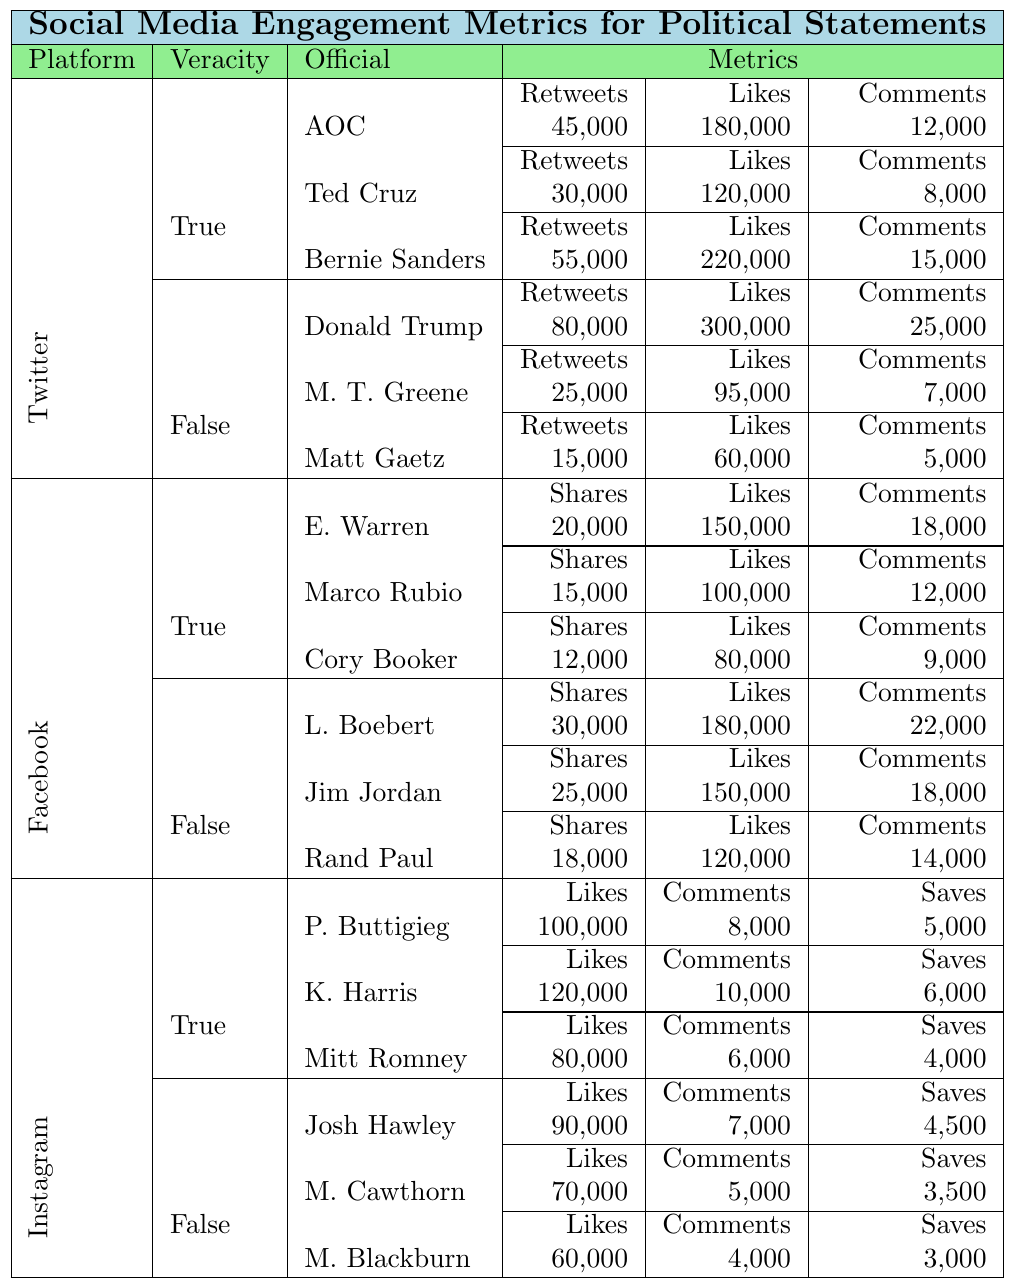What social media platform had the highest engagement for false statements? The highest engagement for false statements can be found by comparing the total of retweets, likes, and comments across the platforms. Twitter's highest false statement engagement is from Donald Trump with 80,000 retweets, 300,000 likes, and 25,000 comments, totaling 405,000. This is higher than other platforms' totals.
Answer: Twitter What is the total number of likes for true statements made by Alexandria Ocasio-Cortez and Bernie Sanders on Twitter? For Alexandria Ocasio-Cortez, the likes total 180,000 and for Bernie Sanders it is 220,000. The total likes are 180,000 + 220,000 = 400,000.
Answer: 400,000 Which official received the most comments for true statements on Facebook? The official with the most comments for true statements on Facebook is Elizabeth Warren, who received 18,000 comments.
Answer: Elizabeth Warren Did Marjorie Taylor Greene have more likes or comments for false statements on Twitter? Marjorie Taylor Greene received 95,000 likes and 7,000 comments for false statements. Since 95,000 is greater than 7,000, she had more likes than comments.
Answer: Likes What is the average engagement (retweets, likes, comments) for true statements on Twitter? To find the average engagement for true statements, sum the metrics: (45,000 + 180,000 + 12,000) + (30,000 + 120,000 + 8,000) + (55,000 + 220,000 + 15,000) = 450,000. There are 9 data points (3 metrics × 3 officials). Average is 450,000 / 9 = 50,000.
Answer: 50,000 Which social media platform had the least engagement for true statements? Calculate the total for true statements on each platform: Twitter (450,000), Facebook (320,000), Instagram (360,000). Facebook has the least engagement at 320,000.
Answer: Facebook How many total shares were there for false statements on Facebook from all officials? Lauren Boebert had 30,000 shares, Jim Jordan had 25,000 shares, and Rand Paul had 18,000 shares. The total is 30,000 + 25,000 + 18,000 = 73,000 shares.
Answer: 73,000 Which official had the highest number of likes for false statements on Instagram? On Instagram, Josh Hawley had 90,000 likes for false statements, which is the highest among the officials listed.
Answer: Josh Hawley Calculate the difference in comments between true statements by Cory Booker and false statements by Rand Paul on Facebook. Cory Booker had 9,000 comments for true statements, and Rand Paul had 14,000 comments for false statements. The difference is 14,000 - 9,000 = 5,000 comments.
Answer: 5,000 Which official has the highest engagement across all platforms for true statements? To find the highest engagement for true statements, compare totals. Bernie Sanders on Twitter has 55,000 retweets + 220,000 likes + 15,000 comments = 290,000. Comparatively, Alexandria Ocasio-Cortez has 180,000, and among Facebook and Instagram officials, the totals are lower than 290,000.
Answer: Bernie Sanders Did any official have equal likes and comments for their true statements? Reviewing the table, no official had equal likes and comments across all officials for true statements. The metrics differ for each statement.
Answer: No 